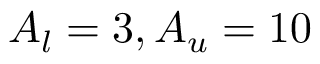Convert formula to latex. <formula><loc_0><loc_0><loc_500><loc_500>A _ { l } = 3 , A _ { u } = 1 0</formula> 